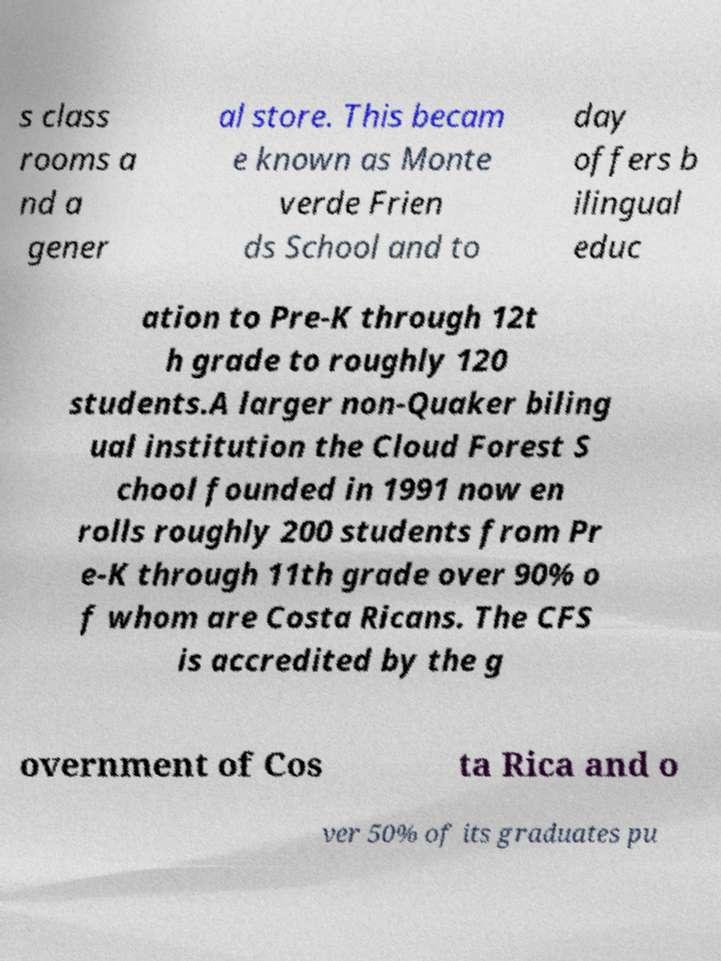I need the written content from this picture converted into text. Can you do that? s class rooms a nd a gener al store. This becam e known as Monte verde Frien ds School and to day offers b ilingual educ ation to Pre-K through 12t h grade to roughly 120 students.A larger non-Quaker biling ual institution the Cloud Forest S chool founded in 1991 now en rolls roughly 200 students from Pr e-K through 11th grade over 90% o f whom are Costa Ricans. The CFS is accredited by the g overnment of Cos ta Rica and o ver 50% of its graduates pu 